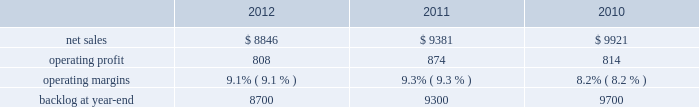Aeronautics 2019 operating profit for 2011 increased $ 132 million , or 9% ( 9 % ) , compared to 2010 .
The increase primarily was attributable to approximately $ 115 million of higher operating profit on c-130 programs due to increased volume and the retirement of risks ; increased volume and risk retirements on f-16 programs of about $ 50 million and c-5 programs of approximately $ 20 million ; and about $ 70 million due to risk retirements on other aeronautics sustainment activities in 2011 .
These increases partially were offset by a decline in operating profit of approximately $ 75 million on the f-22 program and f-35 development contract primarily due to lower volume and about $ 55 million on other programs , including f-35 lrip , primarily due to lower profit rate adjustments in 2011 compared to 2010 .
Adjustments not related to volume , including net profit rate adjustments described above , were approximately $ 90 million higher in 2011 compared to 2010 .
Backlog backlog decreased in 2012 compared to 2011 mainly due to lower orders on f-35 contracts and c-130 programs , partially offset by higher orders on f-16 programs .
Backlog increased in 2011 compared to 2010 mainly due to higher orders on f-35 contracts , which partially were offset by higher sales volume on the c-130 programs .
Trends we expect aeronautics will experience a mid single digit percentage range decline in net sales for 2013 as compared to 2012 .
A decrease in net sales from a decline in f-16 and c-130j aircraft deliveries is expected to be partially offset by an increase in net sales volume on f-35 lrip contracts .
Operating profit is projected to decrease at a high single digit percentage range from 2012 levels due to the expected decline in net sales as well as changes in aircraft mix , resulting in a slight decline in operating margins between the years .
Information systems & global solutions our is&gs business segment provides management services , integrated information technology solutions , and advanced technology systems and expertise across a broad spectrum of applications for civil , defense , intelligence , and other government customers .
Is&gs has a portfolio of many smaller contracts as compared to our other business segments .
Is&gs has been impacted by the continuing downturn in the federal information technology budgets and the impact of the continuing resolution that was effective on october 1 , 2012 , the start of the u.s .
Government 2019s fiscal year .
Is&gs 2019 operating results included the following ( in millions ) : .
2012 compared to 2011 is&gs 2019 net sales for 2012 decreased $ 535 million , or 6% ( 6 % ) , compared to 2011 .
The decrease was attributable to lower net sales of approximately $ 485 million due to the substantial completion of various programs during 2011 ( primarily jtrs ; odin ; and u.k .
Census ) ; and about $ 255 million due to lower volume on numerous other programs ( primarily hanford ; warfighter information network-tactical ( win-t ) ; command , control , battle management and communications ( c2bmc ) ; and transportation worker identification credential ( twic ) ) .
Partially offsetting the decreases were higher net sales of approximately $ 140 million from qtc , which was acquired early in the fourth quarter of 2011 ; and about $ 65 million from increased activity on numerous other programs , primarily federal cyber security programs and persistent threat detection system ( ptds ) operational support .
Is&gs 2019 operating profit for 2012 decreased $ 66 million , or 8% ( 8 % ) , compared to 2011 .
The decrease was attributable to lower operating profit of approximately $ 50 million due to the favorable impact of the odin contract completion in 2011 ; about $ 25 million due to an increase in reserves for performance issues related to an international airborne surveillance system in 2012 ; and approximately $ 20 million due to lower volume on certain programs ( primarily c2bmc and win-t ) .
Partially offsetting the decreases was an increase in operating profit due to higher risk retirements of approximately $ 15 million from the twic program ; and about $ 10 million due to increased activity on numerous other programs , primarily federal cyber security programs and ptds operational support .
Operating profit for the jtrs program was comparable as a decrease in volume was offset by a decrease in reserves .
Adjustments not related to volume , including net profit booking rate adjustments and other matters described above , were approximately $ 20 million higher for 2012 compared to 2011. .
What was the percent of the increase in the operating profit from 2010 to 2011? 
Computations: ((874 - 814) / 814)
Answer: 0.07371. Aeronautics 2019 operating profit for 2011 increased $ 132 million , or 9% ( 9 % ) , compared to 2010 .
The increase primarily was attributable to approximately $ 115 million of higher operating profit on c-130 programs due to increased volume and the retirement of risks ; increased volume and risk retirements on f-16 programs of about $ 50 million and c-5 programs of approximately $ 20 million ; and about $ 70 million due to risk retirements on other aeronautics sustainment activities in 2011 .
These increases partially were offset by a decline in operating profit of approximately $ 75 million on the f-22 program and f-35 development contract primarily due to lower volume and about $ 55 million on other programs , including f-35 lrip , primarily due to lower profit rate adjustments in 2011 compared to 2010 .
Adjustments not related to volume , including net profit rate adjustments described above , were approximately $ 90 million higher in 2011 compared to 2010 .
Backlog backlog decreased in 2012 compared to 2011 mainly due to lower orders on f-35 contracts and c-130 programs , partially offset by higher orders on f-16 programs .
Backlog increased in 2011 compared to 2010 mainly due to higher orders on f-35 contracts , which partially were offset by higher sales volume on the c-130 programs .
Trends we expect aeronautics will experience a mid single digit percentage range decline in net sales for 2013 as compared to 2012 .
A decrease in net sales from a decline in f-16 and c-130j aircraft deliveries is expected to be partially offset by an increase in net sales volume on f-35 lrip contracts .
Operating profit is projected to decrease at a high single digit percentage range from 2012 levels due to the expected decline in net sales as well as changes in aircraft mix , resulting in a slight decline in operating margins between the years .
Information systems & global solutions our is&gs business segment provides management services , integrated information technology solutions , and advanced technology systems and expertise across a broad spectrum of applications for civil , defense , intelligence , and other government customers .
Is&gs has a portfolio of many smaller contracts as compared to our other business segments .
Is&gs has been impacted by the continuing downturn in the federal information technology budgets and the impact of the continuing resolution that was effective on october 1 , 2012 , the start of the u.s .
Government 2019s fiscal year .
Is&gs 2019 operating results included the following ( in millions ) : .
2012 compared to 2011 is&gs 2019 net sales for 2012 decreased $ 535 million , or 6% ( 6 % ) , compared to 2011 .
The decrease was attributable to lower net sales of approximately $ 485 million due to the substantial completion of various programs during 2011 ( primarily jtrs ; odin ; and u.k .
Census ) ; and about $ 255 million due to lower volume on numerous other programs ( primarily hanford ; warfighter information network-tactical ( win-t ) ; command , control , battle management and communications ( c2bmc ) ; and transportation worker identification credential ( twic ) ) .
Partially offsetting the decreases were higher net sales of approximately $ 140 million from qtc , which was acquired early in the fourth quarter of 2011 ; and about $ 65 million from increased activity on numerous other programs , primarily federal cyber security programs and persistent threat detection system ( ptds ) operational support .
Is&gs 2019 operating profit for 2012 decreased $ 66 million , or 8% ( 8 % ) , compared to 2011 .
The decrease was attributable to lower operating profit of approximately $ 50 million due to the favorable impact of the odin contract completion in 2011 ; about $ 25 million due to an increase in reserves for performance issues related to an international airborne surveillance system in 2012 ; and approximately $ 20 million due to lower volume on certain programs ( primarily c2bmc and win-t ) .
Partially offsetting the decreases was an increase in operating profit due to higher risk retirements of approximately $ 15 million from the twic program ; and about $ 10 million due to increased activity on numerous other programs , primarily federal cyber security programs and ptds operational support .
Operating profit for the jtrs program was comparable as a decrease in volume was offset by a decrease in reserves .
Adjustments not related to volume , including net profit booking rate adjustments and other matters described above , were approximately $ 20 million higher for 2012 compared to 2011. .
What is the growth rate in net sales for is&gs in 2011? 
Computations: ((9381 - 9921) / 9921)
Answer: -0.05443. 